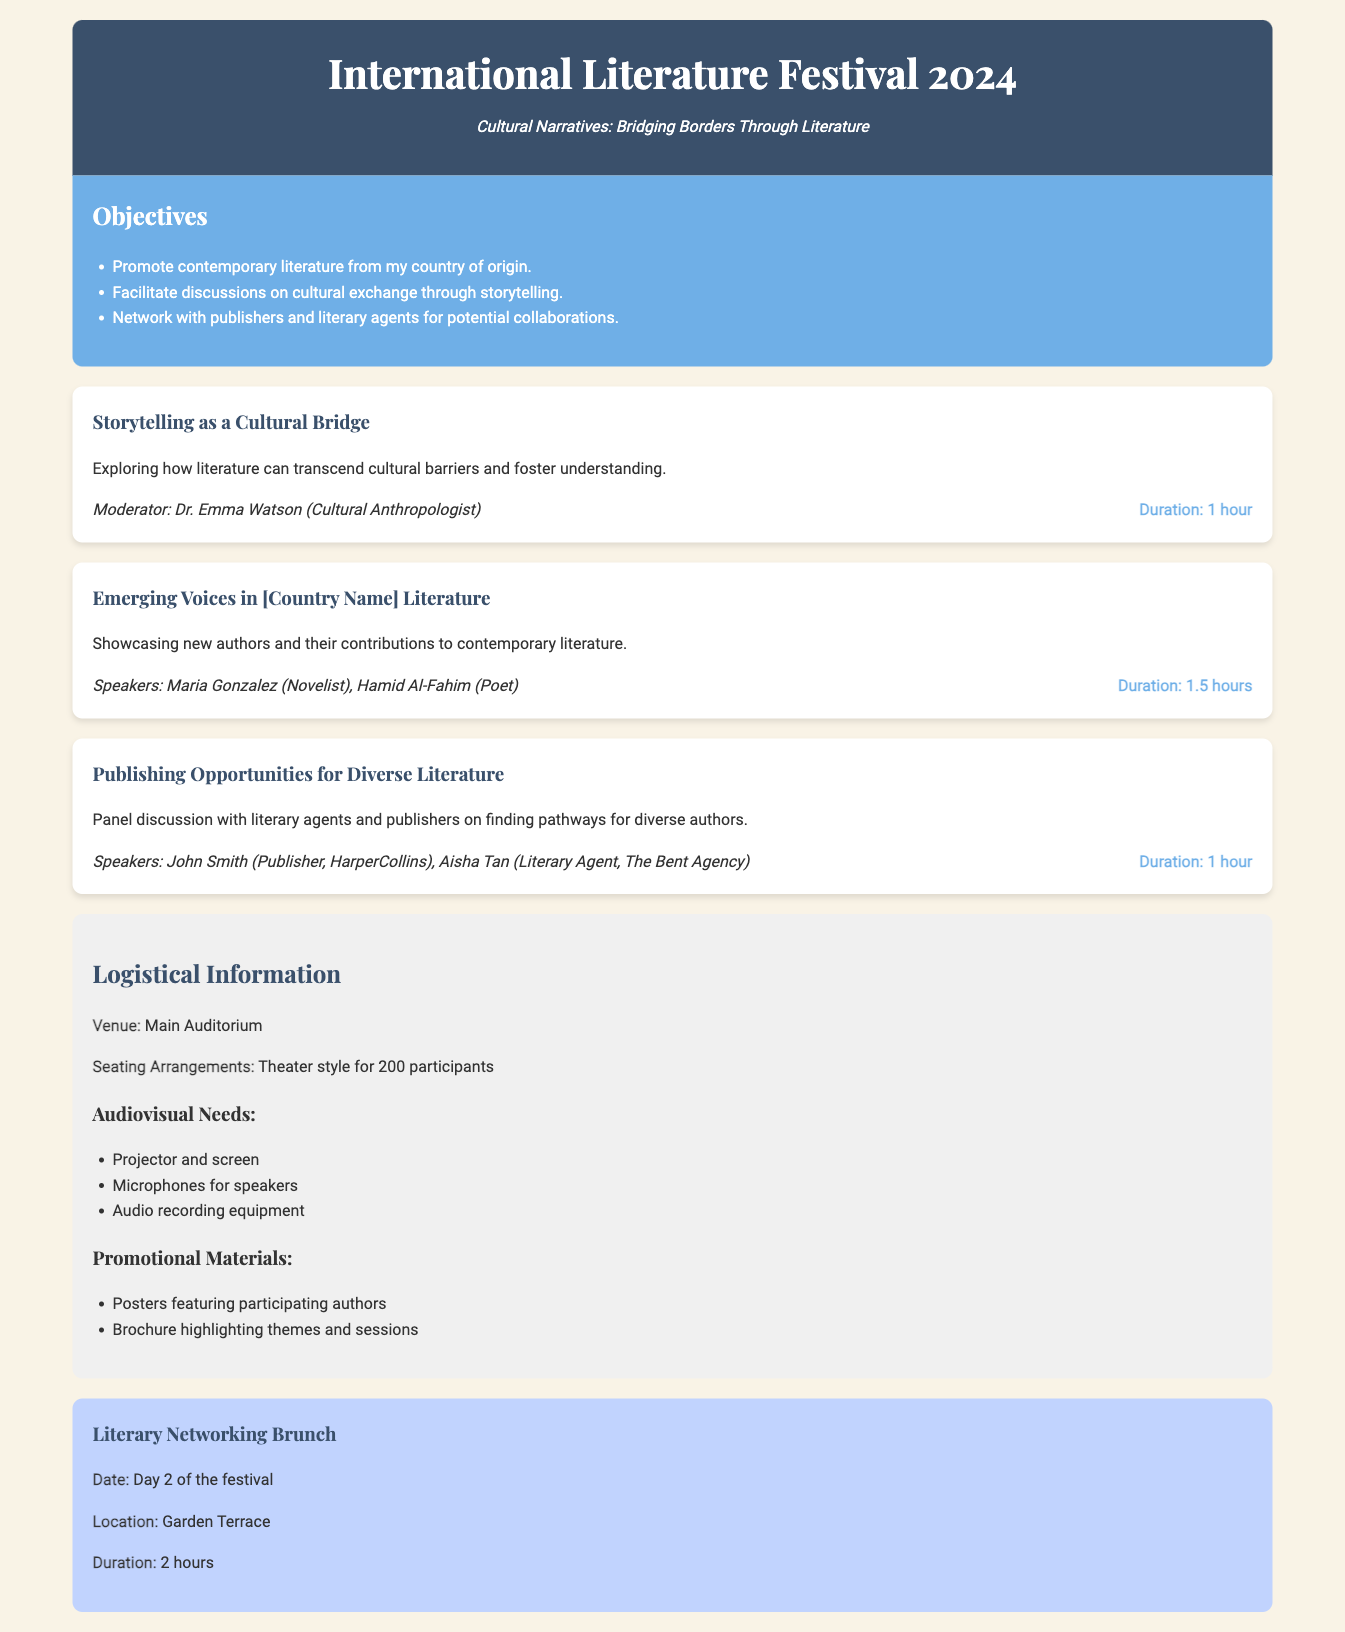what is the theme of the festival? The theme is highlighted in the header section of the document as "Cultural Narratives: Bridging Borders Through Literature."
Answer: Cultural Narratives: Bridging Borders Through Literature who is the moderator for the first session? The session titled "Storytelling as a Cultural Bridge" lists Dr. Emma Watson as the moderator.
Answer: Dr. Emma Watson how long is the session "Emerging Voices in [Country Name] Literature"? The duration for this session, as specified in the session details, is 1.5 hours.
Answer: 1.5 hours what is the date of the networking brunch? The networking event will occur on "Day 2 of the festival," according to its description.
Answer: Day 2 of the festival what type of seating arrangement is planned for the venue? The document states that the seating arrangements will be theater style for 200 participants.
Answer: Theater style for 200 participants who are the speakers for the session on publishing opportunities? The speakers listed for the session "Publishing Opportunities for Diverse Literature" are John Smith and Aisha Tan.
Answer: John Smith, Aisha Tan what are the audiovisual needs mentioned? The logistical section includes a list of audiovisual needs such as projector and screen, microphones, and audio recording equipment.
Answer: Projector and screen, microphones for speakers, audio recording equipment how long will the literary networking brunch last? The information provided states that the literary networking brunch has a duration of 2 hours.
Answer: 2 hours 